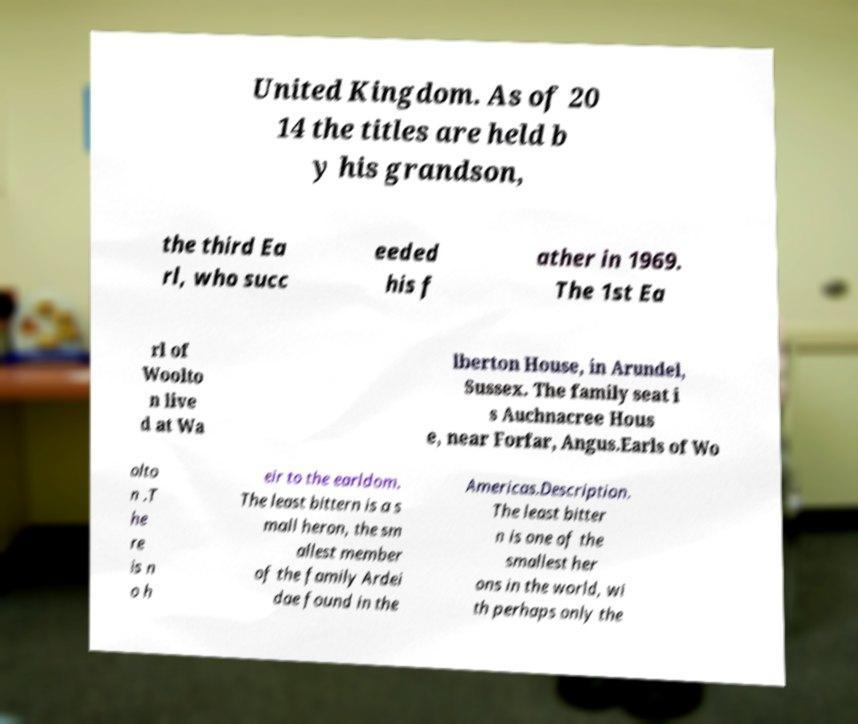Can you read and provide the text displayed in the image?This photo seems to have some interesting text. Can you extract and type it out for me? United Kingdom. As of 20 14 the titles are held b y his grandson, the third Ea rl, who succ eeded his f ather in 1969. The 1st Ea rl of Woolto n live d at Wa lberton House, in Arundel, Sussex. The family seat i s Auchnacree Hous e, near Forfar, Angus.Earls of Wo olto n .T he re is n o h eir to the earldom. The least bittern is a s mall heron, the sm allest member of the family Ardei dae found in the Americas.Description. The least bitter n is one of the smallest her ons in the world, wi th perhaps only the 